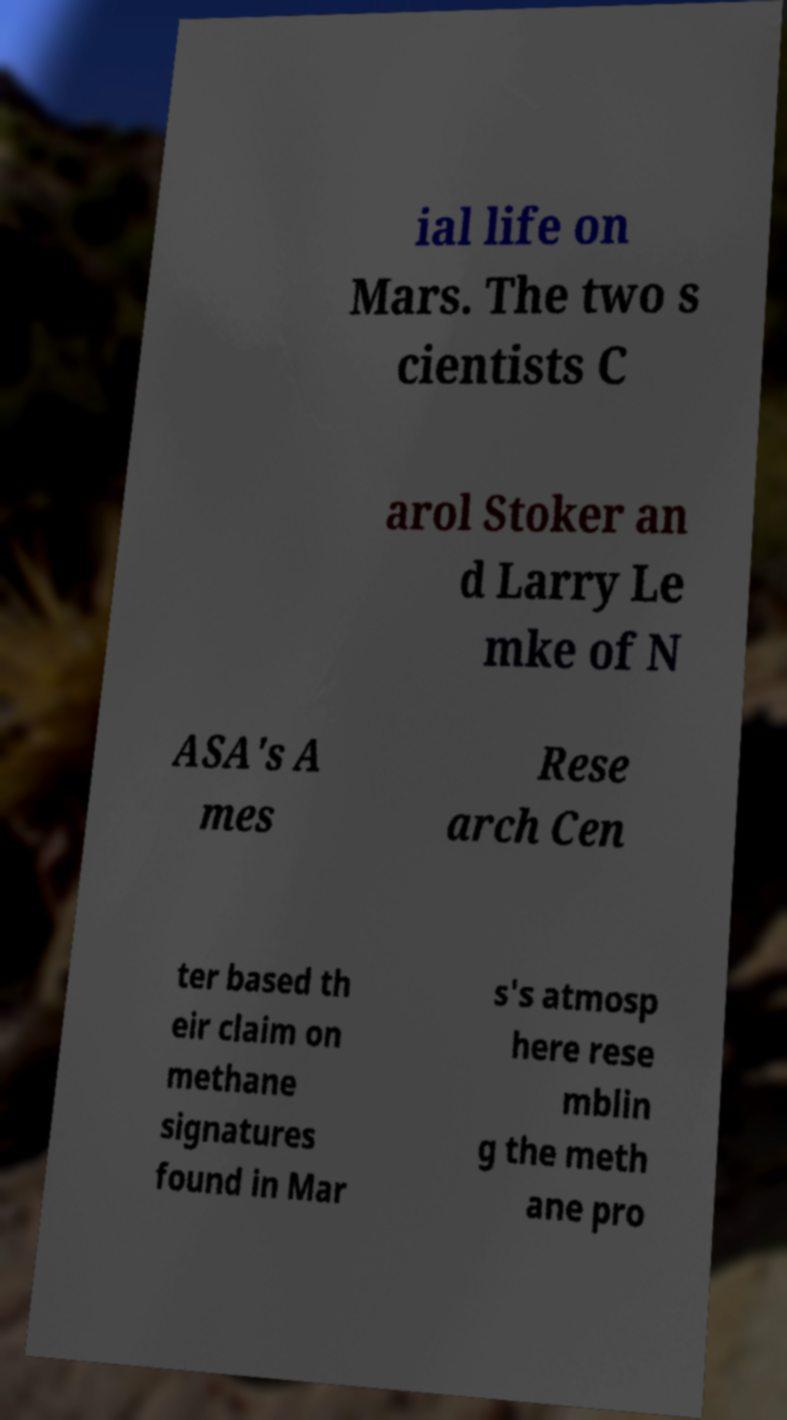Could you assist in decoding the text presented in this image and type it out clearly? ial life on Mars. The two s cientists C arol Stoker an d Larry Le mke of N ASA's A mes Rese arch Cen ter based th eir claim on methane signatures found in Mar s's atmosp here rese mblin g the meth ane pro 